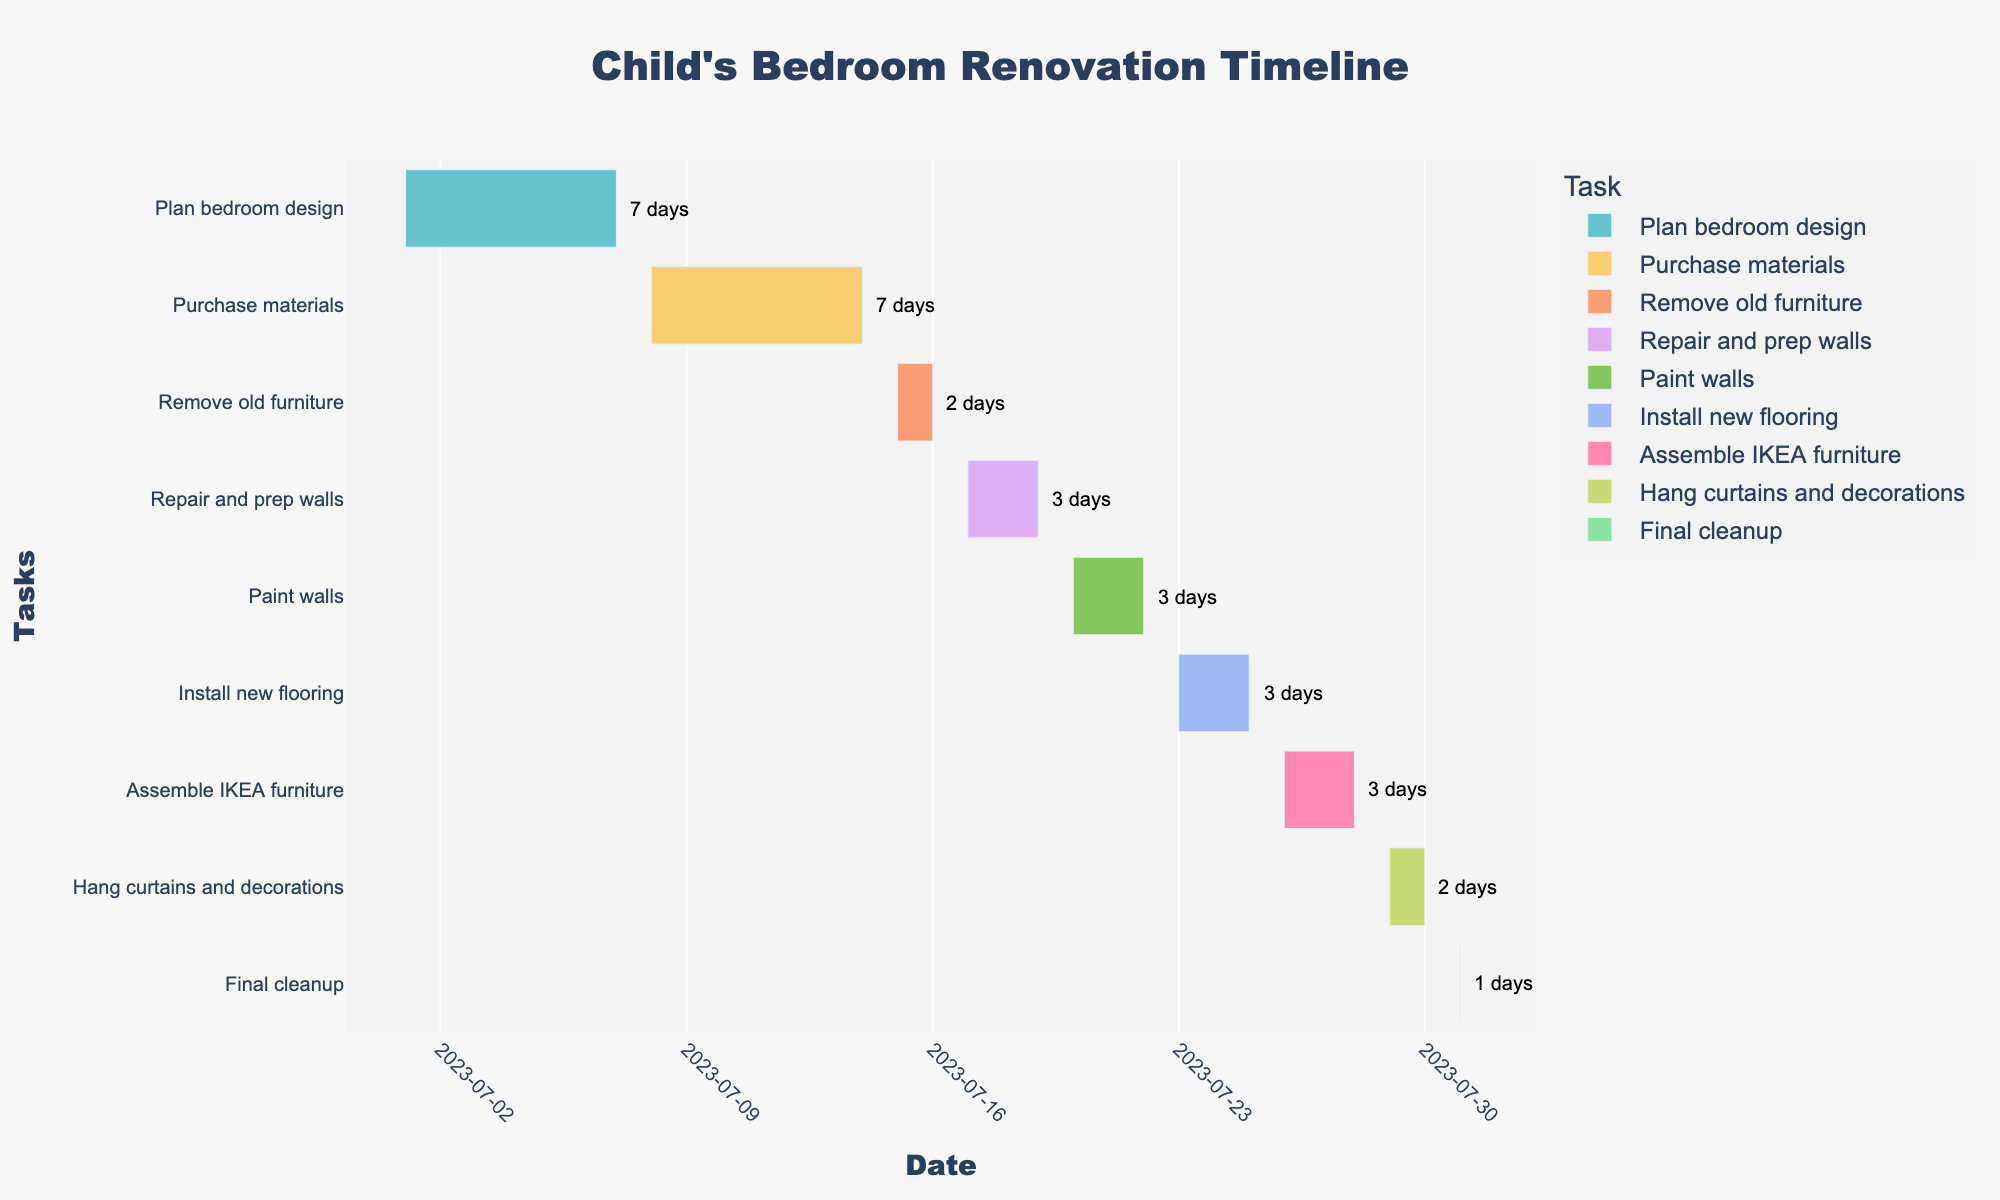What's the title of the chart? The title of the chart is displayed at the top center. According to the code, the title set is "Child's Bedroom Renovation Timeline."
Answer: Child's Bedroom Renovation Timeline What color scheme is used for the tasks? The tasks in the Gantt chart use a Pastel color scheme, which is specified in the code as `px.colors.qualitative.Pastel`. Each task is assigned a different pastel color.
Answer: Pastel color scheme How many days are allocated for painting walls? According to the hover information or annotations on the chart, the "Paint walls" task has a duration of 3 days, from 2023-07-20 to 2023-07-22.
Answer: 3 days Which task has the shortest duration and how long is it? By examining the chart, the "Final cleanup" task has the shortest duration, which is 1 day on 2023-07-31.
Answer: Final cleanup, 1 day What is the total number of tasks in the project? Count the number of distinct tasks shown on the y-axis labels of the Gantt chart. There are 9 tasks in total.
Answer: 9 tasks How long is the entire renovation project from start to finish? The timeline spans from the start date of the first task ("Plan bedroom design" on 2023-07-01) to the end date of the last task ("Final cleanup" on 2023-07-31). This is 31 days.
Answer: 31 days Compare the durations of "Remove old furniture" and "Hang curtains and decorations." Which one is longer and by how many days? "Remove old furniture" lasts for 2 days, while "Hang curtains and decorations" also lasts for 2 days. Therefore, their durations are equal.
Answer: Durations are equal Which tasks overlap in time? By looking at the Gantt chart's bars, "Repair and prep walls" (2023-07-17 to 2023-07-19) and "Paint walls" (2023-07-20 to 2023-07-22) follow each other without overlapping. No tasks appear to overlap in their durations.
Answer: No tasks overlap Which task immediately follows "Install new flooring"? The Gantt chart shows that "Assemble IKEA furniture" starts right after "Install new flooring," on 2023-07-26.
Answer: Assemble IKEA furniture 